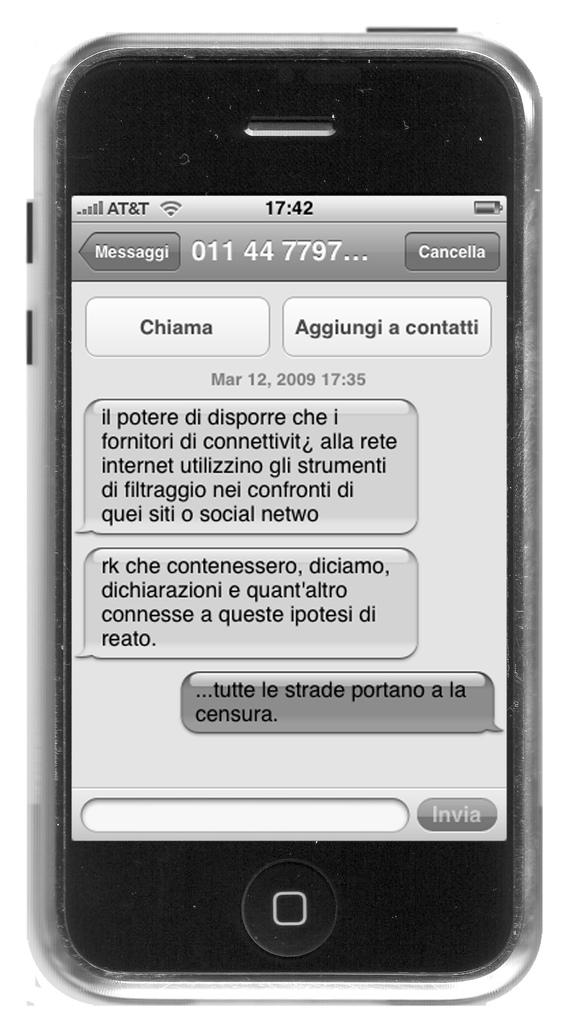What carrier is this iphone with in the top left corner?
Your answer should be very brief. At&t. What app is open on the phone?
Provide a short and direct response. Unanswerable. 